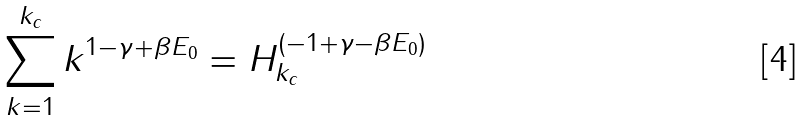<formula> <loc_0><loc_0><loc_500><loc_500>\sum _ { k = 1 } ^ { k _ { c } } k ^ { 1 - \gamma + \beta E _ { 0 } } = H _ { k _ { c } } ^ { ( - 1 + \gamma - \beta E _ { 0 } ) }</formula> 